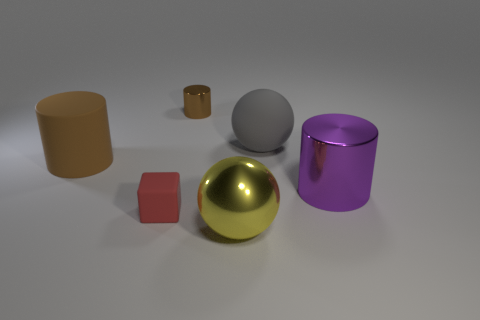Add 4 brown shiny cylinders. How many objects exist? 10 Subtract all spheres. How many objects are left? 4 Add 6 purple shiny cylinders. How many purple shiny cylinders exist? 7 Subtract 0 red cylinders. How many objects are left? 6 Subtract all large rubber things. Subtract all metal spheres. How many objects are left? 3 Add 4 red things. How many red things are left? 5 